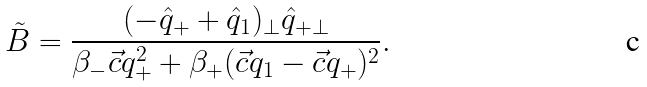<formula> <loc_0><loc_0><loc_500><loc_500>\tilde { B } = \frac { ( - \hat { q } _ { + } + \hat { q } _ { 1 } ) _ { \bot } \hat { q } _ { + \bot } } { \beta _ { - } \vec { c } { q } _ { + } ^ { 2 } + \beta _ { + } ( \vec { c } { q } _ { 1 } - \vec { c } { q } _ { + } ) ^ { 2 } } .</formula> 